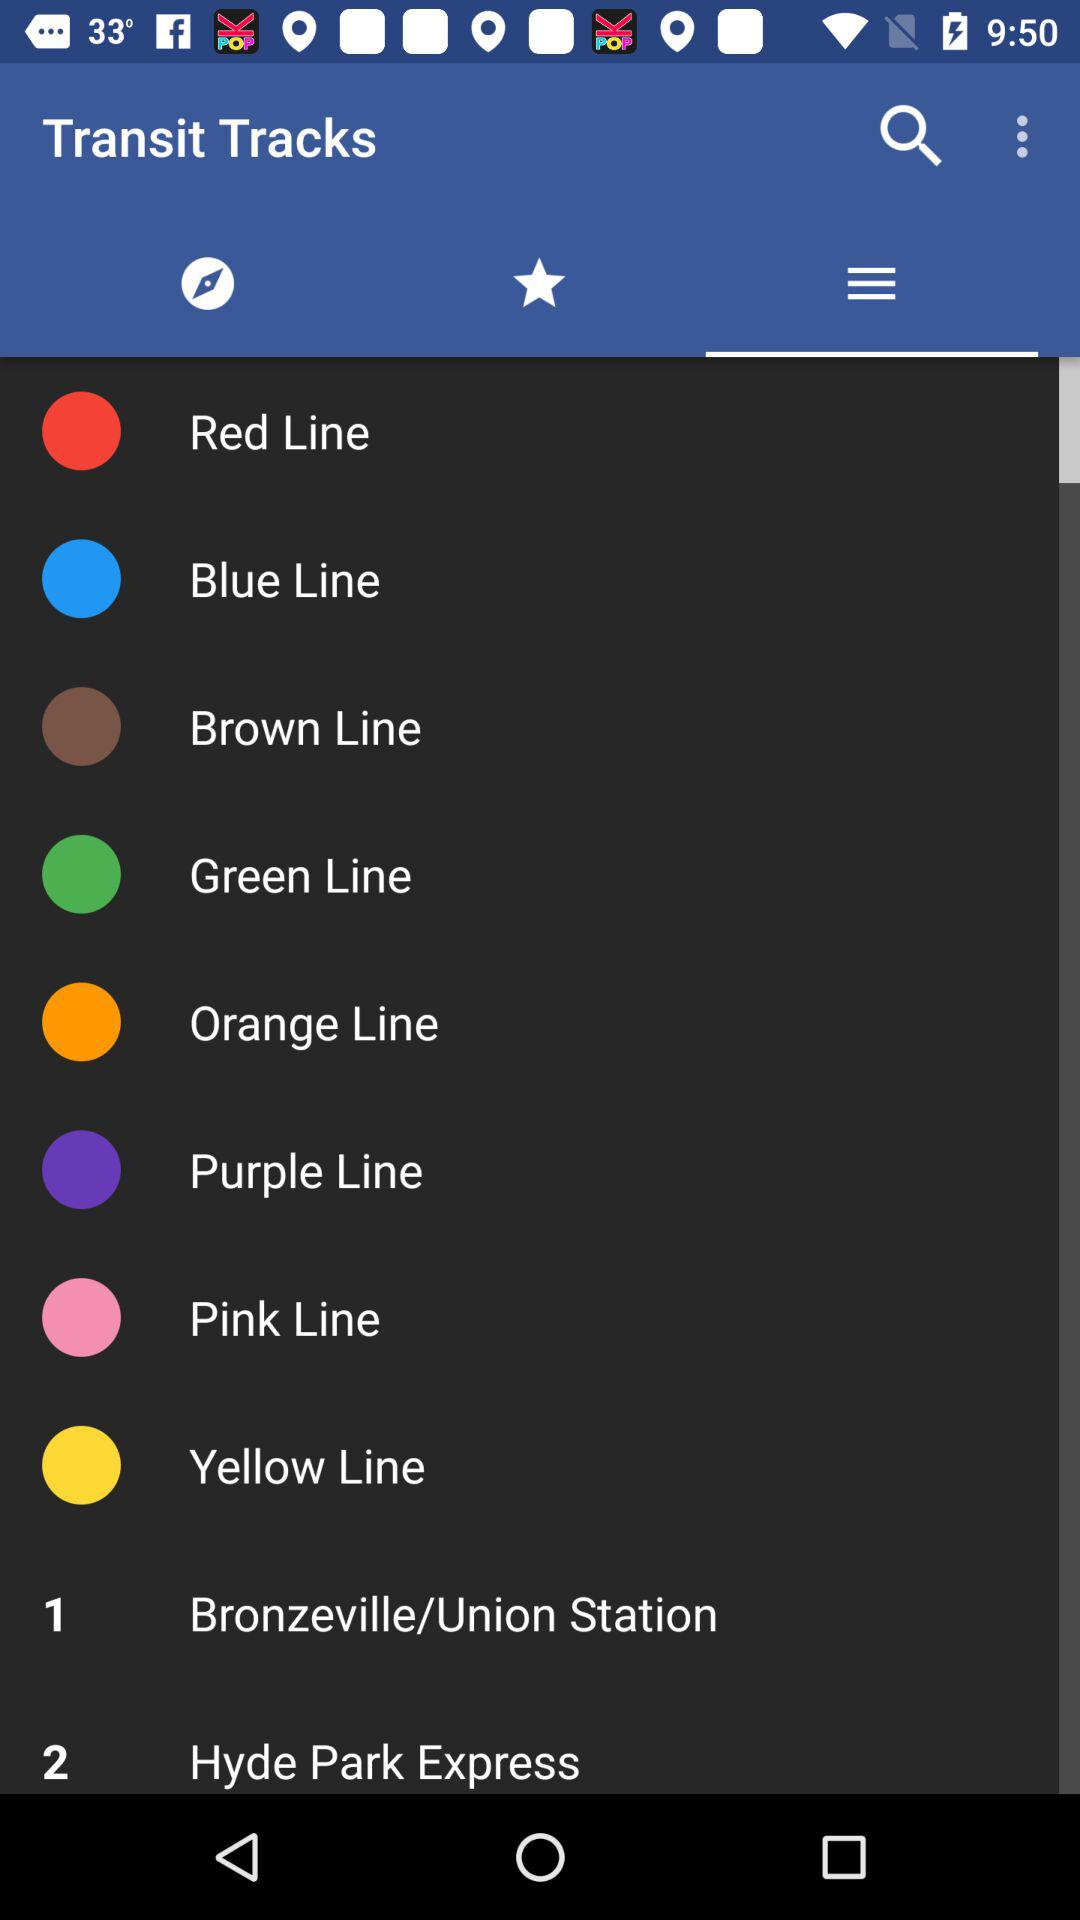What is the name of the application? The name of the application is "Transit Tracks". 